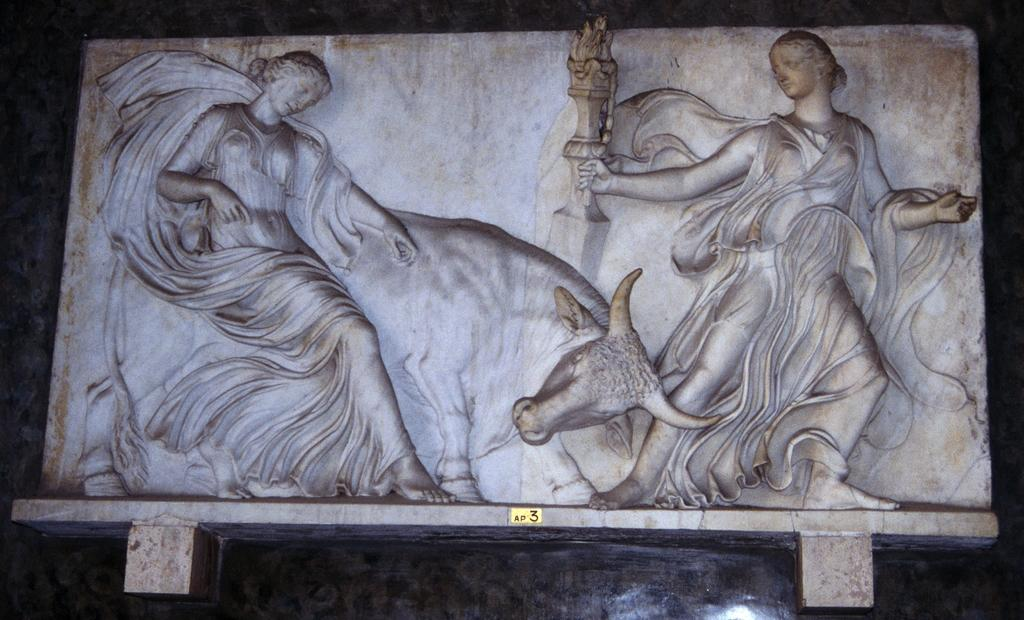What type of statues can be seen in the image? There are stone carved statues of women and a cow in the image. What material are the statues made of? The statues are made of stone. What is the color of the background in the image? The background of the image is black in color. How many cars can be seen in the image? There are no cars present in the image. What type of maid is depicted in the image? There is no maid depicted in the image; it features stone carved statues of women and a cow. 